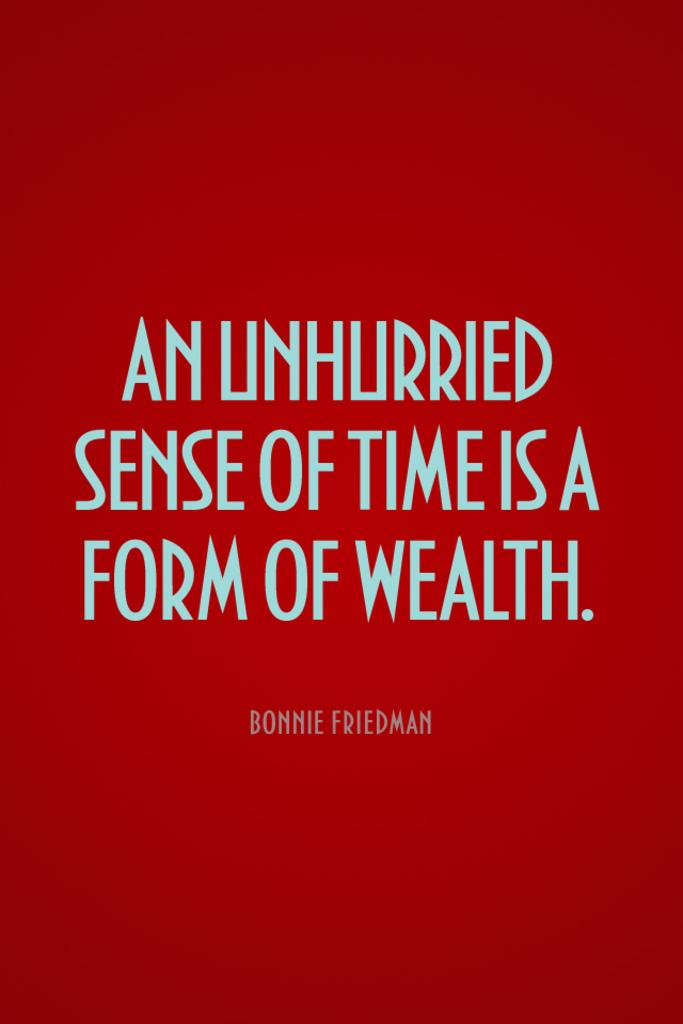<image>
Give a short and clear explanation of the subsequent image. Red background with words that were written by Bonnie Friedman. 